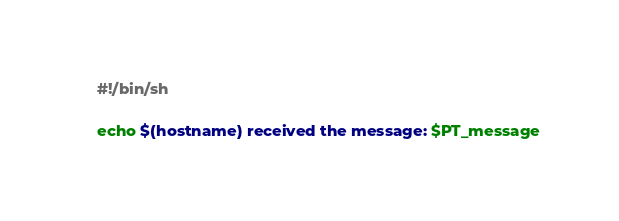<code> <loc_0><loc_0><loc_500><loc_500><_Bash_>#!/bin/sh

echo $(hostname) received the message: $PT_message
</code> 